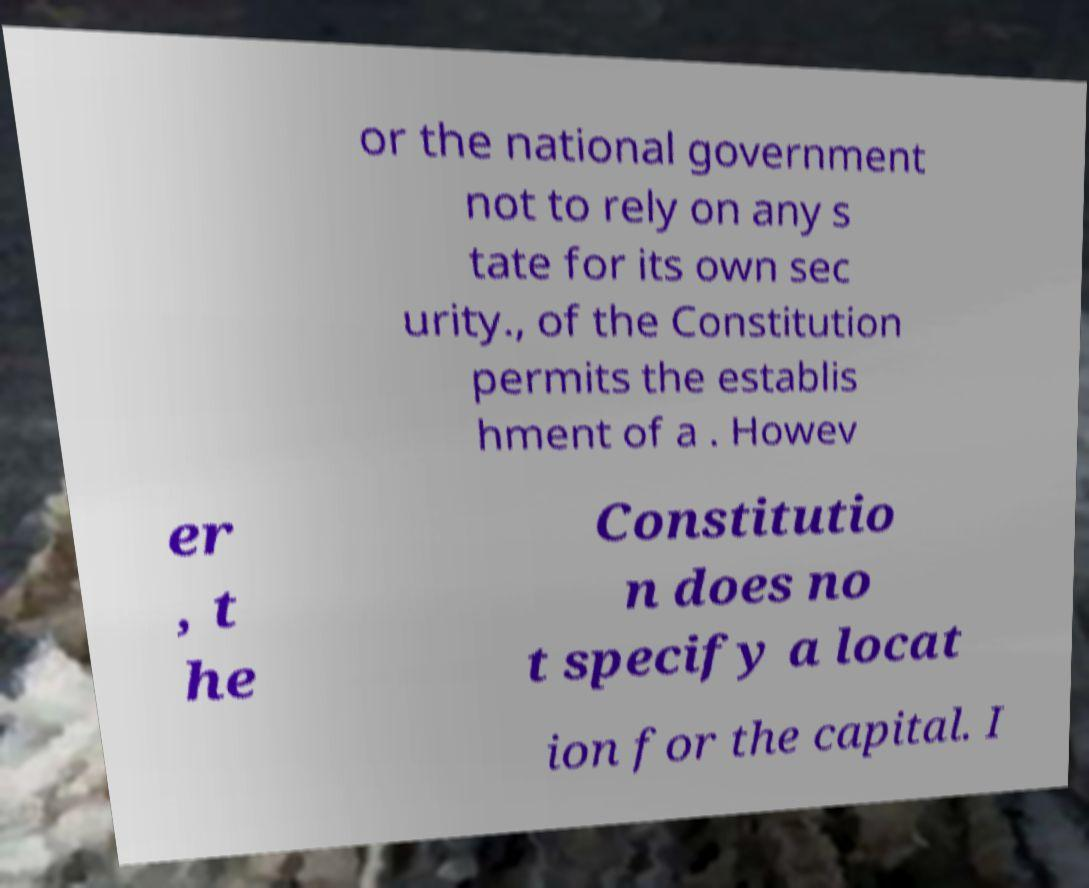Could you assist in decoding the text presented in this image and type it out clearly? or the national government not to rely on any s tate for its own sec urity., of the Constitution permits the establis hment of a . Howev er , t he Constitutio n does no t specify a locat ion for the capital. I 